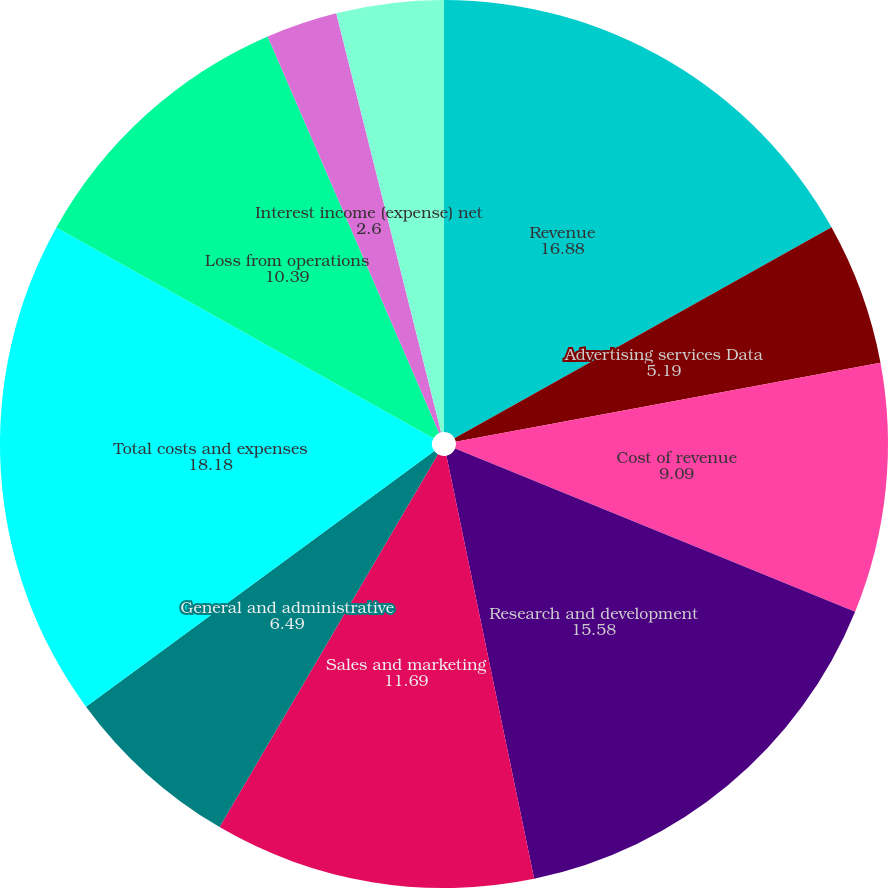Convert chart to OTSL. <chart><loc_0><loc_0><loc_500><loc_500><pie_chart><fcel>Revenue<fcel>Advertising services Data<fcel>Cost of revenue<fcel>Research and development<fcel>Sales and marketing<fcel>General and administrative<fcel>Total costs and expenses<fcel>Loss from operations<fcel>Interest income (expense) net<fcel>Other income (expense) net<nl><fcel>16.88%<fcel>5.19%<fcel>9.09%<fcel>15.58%<fcel>11.69%<fcel>6.49%<fcel>18.18%<fcel>10.39%<fcel>2.6%<fcel>3.9%<nl></chart> 